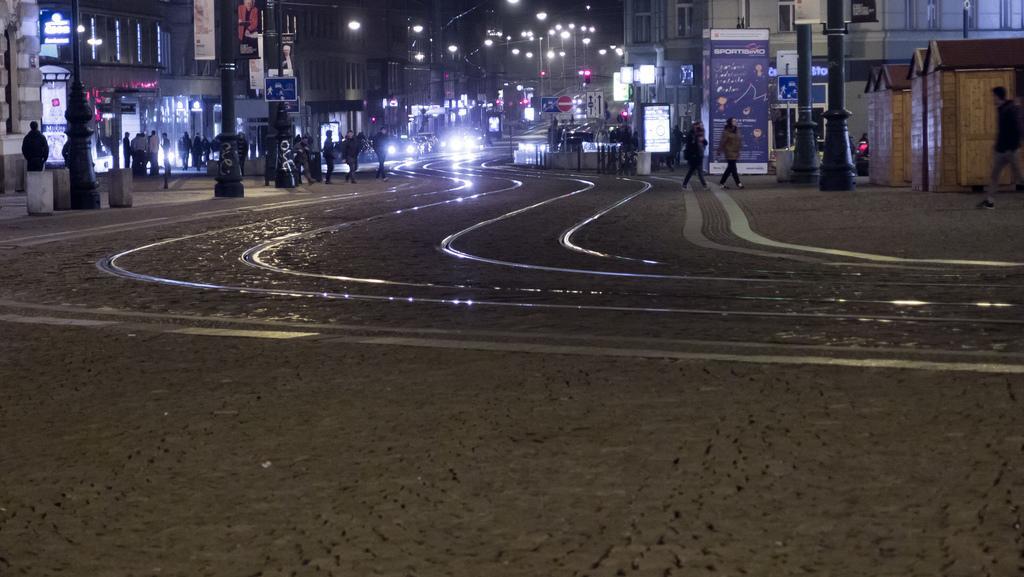Describe this image in one or two sentences. This is a street view image, in this image we can see a few people on the streets, we can also see lamp post, traffic signal lights, direction sign boards, in the background of the image there are buildings. 